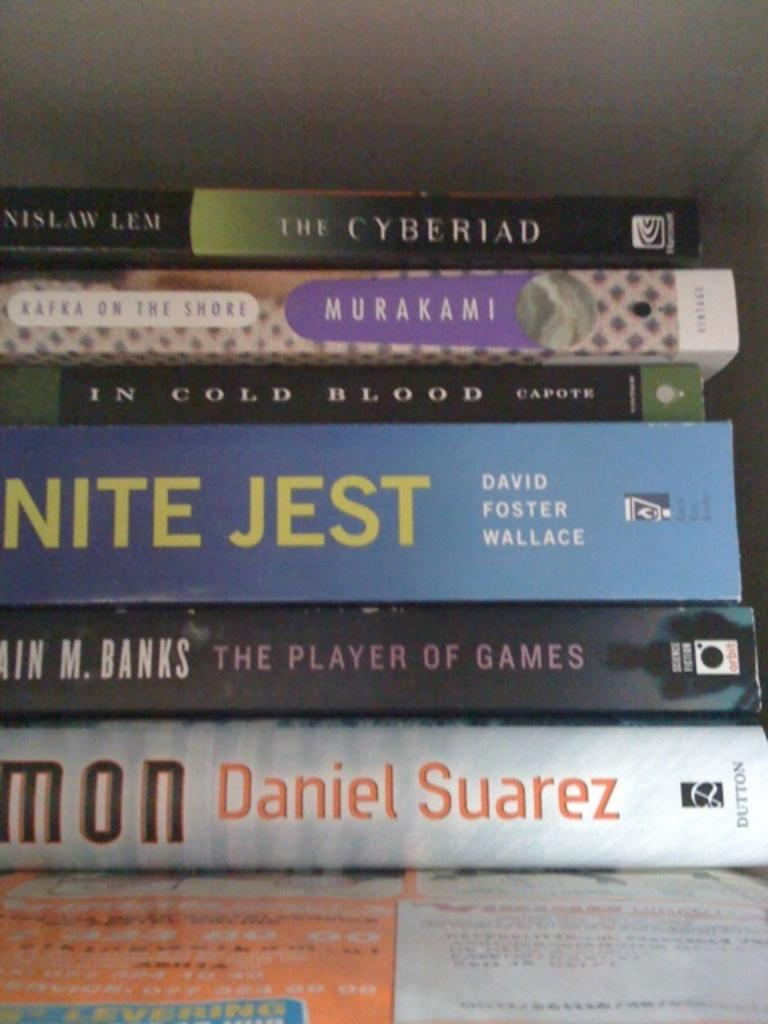<image>
Present a compact description of the photo's key features. Six books sit stacked up including In Cold Blood. 